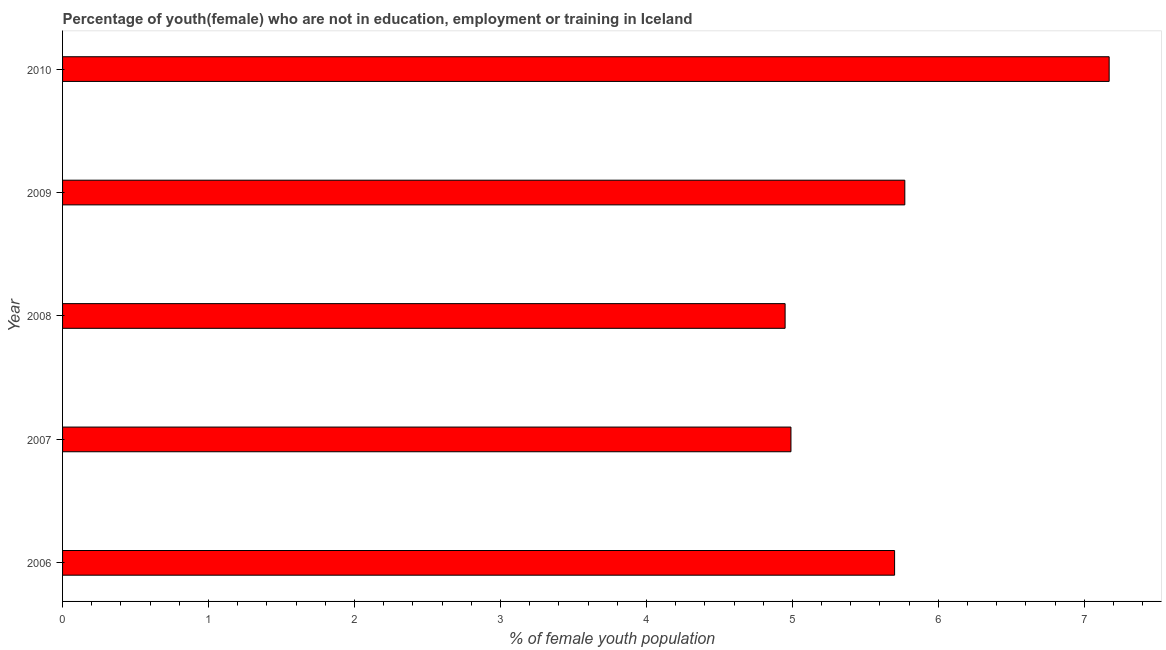Does the graph contain any zero values?
Make the answer very short. No. Does the graph contain grids?
Ensure brevity in your answer.  No. What is the title of the graph?
Your response must be concise. Percentage of youth(female) who are not in education, employment or training in Iceland. What is the label or title of the X-axis?
Ensure brevity in your answer.  % of female youth population. What is the label or title of the Y-axis?
Your answer should be very brief. Year. What is the unemployed female youth population in 2008?
Provide a succinct answer. 4.95. Across all years, what is the maximum unemployed female youth population?
Your answer should be compact. 7.17. Across all years, what is the minimum unemployed female youth population?
Provide a succinct answer. 4.95. What is the sum of the unemployed female youth population?
Your response must be concise. 28.58. What is the average unemployed female youth population per year?
Keep it short and to the point. 5.72. What is the median unemployed female youth population?
Ensure brevity in your answer.  5.7. What is the ratio of the unemployed female youth population in 2009 to that in 2010?
Your answer should be very brief. 0.81. What is the difference between the highest and the second highest unemployed female youth population?
Your answer should be very brief. 1.4. What is the difference between the highest and the lowest unemployed female youth population?
Make the answer very short. 2.22. In how many years, is the unemployed female youth population greater than the average unemployed female youth population taken over all years?
Keep it short and to the point. 2. How many bars are there?
Provide a short and direct response. 5. How many years are there in the graph?
Offer a terse response. 5. What is the difference between two consecutive major ticks on the X-axis?
Ensure brevity in your answer.  1. What is the % of female youth population in 2006?
Give a very brief answer. 5.7. What is the % of female youth population of 2007?
Your answer should be very brief. 4.99. What is the % of female youth population of 2008?
Keep it short and to the point. 4.95. What is the % of female youth population in 2009?
Your answer should be very brief. 5.77. What is the % of female youth population of 2010?
Provide a succinct answer. 7.17. What is the difference between the % of female youth population in 2006 and 2007?
Give a very brief answer. 0.71. What is the difference between the % of female youth population in 2006 and 2008?
Your response must be concise. 0.75. What is the difference between the % of female youth population in 2006 and 2009?
Give a very brief answer. -0.07. What is the difference between the % of female youth population in 2006 and 2010?
Offer a very short reply. -1.47. What is the difference between the % of female youth population in 2007 and 2008?
Give a very brief answer. 0.04. What is the difference between the % of female youth population in 2007 and 2009?
Provide a short and direct response. -0.78. What is the difference between the % of female youth population in 2007 and 2010?
Provide a succinct answer. -2.18. What is the difference between the % of female youth population in 2008 and 2009?
Offer a terse response. -0.82. What is the difference between the % of female youth population in 2008 and 2010?
Make the answer very short. -2.22. What is the difference between the % of female youth population in 2009 and 2010?
Your response must be concise. -1.4. What is the ratio of the % of female youth population in 2006 to that in 2007?
Provide a succinct answer. 1.14. What is the ratio of the % of female youth population in 2006 to that in 2008?
Make the answer very short. 1.15. What is the ratio of the % of female youth population in 2006 to that in 2010?
Your response must be concise. 0.8. What is the ratio of the % of female youth population in 2007 to that in 2008?
Offer a very short reply. 1.01. What is the ratio of the % of female youth population in 2007 to that in 2009?
Ensure brevity in your answer.  0.86. What is the ratio of the % of female youth population in 2007 to that in 2010?
Keep it short and to the point. 0.7. What is the ratio of the % of female youth population in 2008 to that in 2009?
Your answer should be very brief. 0.86. What is the ratio of the % of female youth population in 2008 to that in 2010?
Give a very brief answer. 0.69. What is the ratio of the % of female youth population in 2009 to that in 2010?
Your answer should be compact. 0.81. 